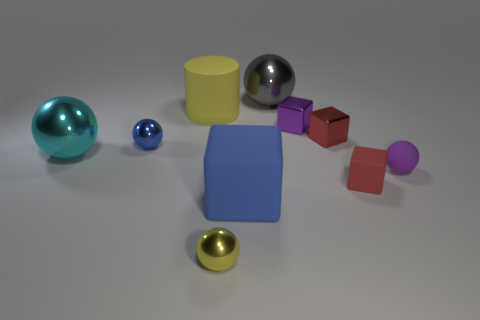Does the tiny metallic sphere that is on the left side of the rubber cylinder have the same color as the big block?
Your response must be concise. Yes. What number of other objects are there of the same shape as the large blue thing?
Your response must be concise. 3. What number of other objects are there of the same material as the tiny purple block?
Your answer should be very brief. 5. What material is the blue object that is on the left side of the small ball in front of the matte block that is behind the large matte cube?
Offer a terse response. Metal. Are the small purple cube and the cylinder made of the same material?
Your answer should be compact. No. What number of blocks are either tiny cyan metallic objects or gray metal objects?
Keep it short and to the point. 0. What is the color of the cube in front of the small red matte object?
Provide a short and direct response. Blue. What number of matte things are either small yellow spheres or tiny gray cylinders?
Offer a terse response. 0. What material is the red thing behind the small object to the left of the large cylinder?
Your answer should be compact. Metal. There is a small object that is the same color as the cylinder; what is its material?
Provide a short and direct response. Metal. 